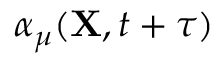Convert formula to latex. <formula><loc_0><loc_0><loc_500><loc_500>\alpha _ { \mu } ( { X } , t + \tau )</formula> 